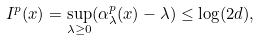Convert formula to latex. <formula><loc_0><loc_0><loc_500><loc_500>I ^ { p } ( x ) = \sup _ { \lambda \geq 0 } ( \alpha _ { \lambda } ^ { p } ( x ) - \lambda ) \leq \log ( 2 d ) ,</formula> 